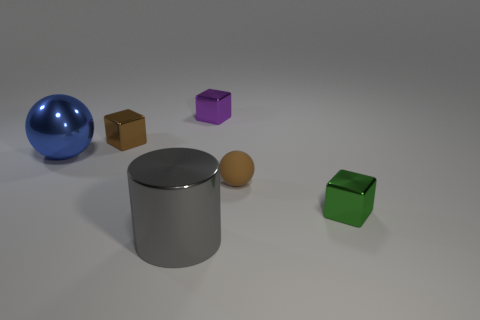There is a small purple object that is made of the same material as the tiny green thing; what is its shape?
Offer a terse response. Cube. Are there any other things that have the same color as the tiny rubber sphere?
Ensure brevity in your answer.  Yes. There is a object left of the brown metallic block that is behind the rubber thing; what number of small shiny blocks are behind it?
Offer a very short reply. 2. What number of cyan things are either spheres or small metal things?
Make the answer very short. 0. There is a brown shiny thing; is its size the same as the purple shiny object on the right side of the gray object?
Make the answer very short. Yes. What material is the tiny purple thing that is the same shape as the tiny brown metallic object?
Ensure brevity in your answer.  Metal. How many other things are there of the same size as the metal cylinder?
Offer a very short reply. 1. What shape is the large object that is in front of the object that is to the left of the brown thing that is to the left of the large gray shiny cylinder?
Make the answer very short. Cylinder. There is a metallic thing that is in front of the tiny purple shiny cube and behind the large blue sphere; what shape is it?
Make the answer very short. Cube. What number of objects are either large blue metal cylinders or brown things behind the big sphere?
Offer a terse response. 1. 